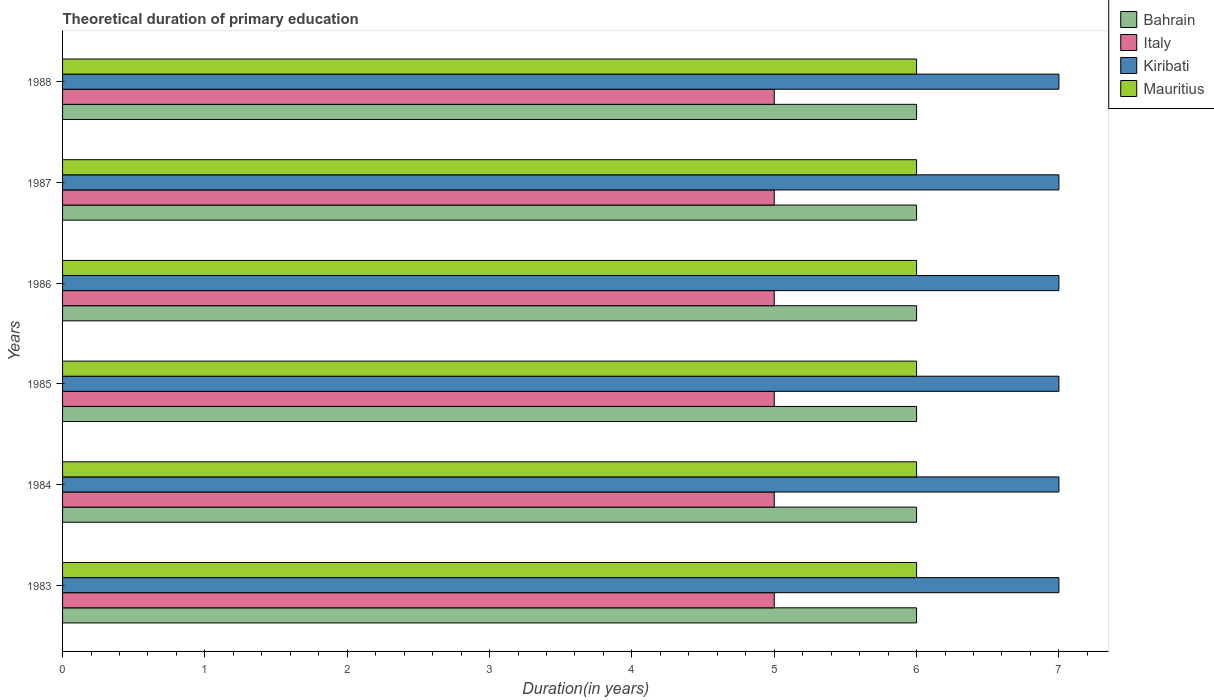How many different coloured bars are there?
Offer a terse response. 4. Are the number of bars per tick equal to the number of legend labels?
Offer a very short reply. Yes. Are the number of bars on each tick of the Y-axis equal?
Give a very brief answer. Yes. What is the label of the 3rd group of bars from the top?
Offer a terse response. 1986. In how many cases, is the number of bars for a given year not equal to the number of legend labels?
Offer a terse response. 0. What is the total theoretical duration of primary education in Mauritius in 1985?
Make the answer very short. 6. Across all years, what is the minimum total theoretical duration of primary education in Mauritius?
Provide a short and direct response. 6. What is the total total theoretical duration of primary education in Kiribati in the graph?
Offer a very short reply. 42. What is the difference between the total theoretical duration of primary education in Italy in 1986 and that in 1987?
Provide a succinct answer. 0. What is the difference between the total theoretical duration of primary education in Bahrain in 1987 and the total theoretical duration of primary education in Italy in 1986?
Your response must be concise. 1. What is the average total theoretical duration of primary education in Kiribati per year?
Keep it short and to the point. 7. In the year 1987, what is the difference between the total theoretical duration of primary education in Kiribati and total theoretical duration of primary education in Mauritius?
Provide a succinct answer. 1. What is the ratio of the total theoretical duration of primary education in Kiribati in 1986 to that in 1987?
Make the answer very short. 1. Is the difference between the total theoretical duration of primary education in Kiribati in 1984 and 1988 greater than the difference between the total theoretical duration of primary education in Mauritius in 1984 and 1988?
Provide a short and direct response. No. What is the difference between the highest and the second highest total theoretical duration of primary education in Bahrain?
Keep it short and to the point. 0. Is it the case that in every year, the sum of the total theoretical duration of primary education in Mauritius and total theoretical duration of primary education in Bahrain is greater than the sum of total theoretical duration of primary education in Kiribati and total theoretical duration of primary education in Italy?
Make the answer very short. No. Is it the case that in every year, the sum of the total theoretical duration of primary education in Italy and total theoretical duration of primary education in Kiribati is greater than the total theoretical duration of primary education in Bahrain?
Give a very brief answer. Yes. How many bars are there?
Offer a very short reply. 24. How many years are there in the graph?
Your answer should be compact. 6. Does the graph contain any zero values?
Give a very brief answer. No. Where does the legend appear in the graph?
Ensure brevity in your answer.  Top right. How many legend labels are there?
Your answer should be very brief. 4. What is the title of the graph?
Give a very brief answer. Theoretical duration of primary education. What is the label or title of the X-axis?
Give a very brief answer. Duration(in years). What is the Duration(in years) of Bahrain in 1983?
Give a very brief answer. 6. What is the Duration(in years) of Italy in 1983?
Offer a terse response. 5. What is the Duration(in years) in Kiribati in 1983?
Provide a succinct answer. 7. What is the Duration(in years) of Italy in 1984?
Offer a very short reply. 5. What is the Duration(in years) in Kiribati in 1984?
Ensure brevity in your answer.  7. What is the Duration(in years) in Bahrain in 1985?
Offer a very short reply. 6. What is the Duration(in years) of Italy in 1985?
Your answer should be compact. 5. What is the Duration(in years) in Kiribati in 1985?
Keep it short and to the point. 7. What is the Duration(in years) in Italy in 1986?
Provide a short and direct response. 5. What is the Duration(in years) in Kiribati in 1986?
Your answer should be very brief. 7. What is the Duration(in years) of Mauritius in 1987?
Keep it short and to the point. 6. What is the Duration(in years) in Italy in 1988?
Make the answer very short. 5. What is the Duration(in years) in Mauritius in 1988?
Give a very brief answer. 6. Across all years, what is the maximum Duration(in years) in Bahrain?
Ensure brevity in your answer.  6. Across all years, what is the minimum Duration(in years) of Bahrain?
Give a very brief answer. 6. Across all years, what is the minimum Duration(in years) of Mauritius?
Provide a succinct answer. 6. What is the total Duration(in years) in Bahrain in the graph?
Offer a terse response. 36. What is the total Duration(in years) of Kiribati in the graph?
Your response must be concise. 42. What is the total Duration(in years) in Mauritius in the graph?
Your response must be concise. 36. What is the difference between the Duration(in years) in Kiribati in 1983 and that in 1984?
Offer a very short reply. 0. What is the difference between the Duration(in years) of Mauritius in 1983 and that in 1984?
Your answer should be compact. 0. What is the difference between the Duration(in years) in Bahrain in 1983 and that in 1985?
Keep it short and to the point. 0. What is the difference between the Duration(in years) in Mauritius in 1983 and that in 1986?
Your answer should be very brief. 0. What is the difference between the Duration(in years) in Bahrain in 1983 and that in 1987?
Provide a succinct answer. 0. What is the difference between the Duration(in years) in Kiribati in 1983 and that in 1987?
Your response must be concise. 0. What is the difference between the Duration(in years) of Mauritius in 1983 and that in 1987?
Offer a terse response. 0. What is the difference between the Duration(in years) in Bahrain in 1983 and that in 1988?
Offer a terse response. 0. What is the difference between the Duration(in years) in Italy in 1983 and that in 1988?
Provide a short and direct response. 0. What is the difference between the Duration(in years) of Kiribati in 1983 and that in 1988?
Ensure brevity in your answer.  0. What is the difference between the Duration(in years) of Bahrain in 1984 and that in 1985?
Your response must be concise. 0. What is the difference between the Duration(in years) in Italy in 1984 and that in 1985?
Offer a terse response. 0. What is the difference between the Duration(in years) in Kiribati in 1984 and that in 1985?
Make the answer very short. 0. What is the difference between the Duration(in years) of Italy in 1984 and that in 1986?
Provide a short and direct response. 0. What is the difference between the Duration(in years) in Mauritius in 1984 and that in 1986?
Make the answer very short. 0. What is the difference between the Duration(in years) in Bahrain in 1984 and that in 1988?
Provide a succinct answer. 0. What is the difference between the Duration(in years) in Italy in 1985 and that in 1986?
Offer a terse response. 0. What is the difference between the Duration(in years) in Kiribati in 1985 and that in 1986?
Keep it short and to the point. 0. What is the difference between the Duration(in years) of Mauritius in 1985 and that in 1987?
Your response must be concise. 0. What is the difference between the Duration(in years) in Kiribati in 1985 and that in 1988?
Ensure brevity in your answer.  0. What is the difference between the Duration(in years) in Mauritius in 1985 and that in 1988?
Provide a succinct answer. 0. What is the difference between the Duration(in years) in Bahrain in 1986 and that in 1987?
Your response must be concise. 0. What is the difference between the Duration(in years) in Italy in 1986 and that in 1987?
Keep it short and to the point. 0. What is the difference between the Duration(in years) of Bahrain in 1986 and that in 1988?
Make the answer very short. 0. What is the difference between the Duration(in years) in Italy in 1986 and that in 1988?
Give a very brief answer. 0. What is the difference between the Duration(in years) in Mauritius in 1986 and that in 1988?
Ensure brevity in your answer.  0. What is the difference between the Duration(in years) of Bahrain in 1987 and that in 1988?
Offer a very short reply. 0. What is the difference between the Duration(in years) in Kiribati in 1987 and that in 1988?
Offer a very short reply. 0. What is the difference between the Duration(in years) in Mauritius in 1987 and that in 1988?
Your response must be concise. 0. What is the difference between the Duration(in years) of Bahrain in 1983 and the Duration(in years) of Kiribati in 1984?
Ensure brevity in your answer.  -1. What is the difference between the Duration(in years) in Italy in 1983 and the Duration(in years) in Kiribati in 1984?
Ensure brevity in your answer.  -2. What is the difference between the Duration(in years) of Italy in 1983 and the Duration(in years) of Mauritius in 1984?
Keep it short and to the point. -1. What is the difference between the Duration(in years) in Kiribati in 1983 and the Duration(in years) in Mauritius in 1984?
Provide a short and direct response. 1. What is the difference between the Duration(in years) of Italy in 1983 and the Duration(in years) of Kiribati in 1985?
Offer a terse response. -2. What is the difference between the Duration(in years) of Kiribati in 1983 and the Duration(in years) of Mauritius in 1985?
Give a very brief answer. 1. What is the difference between the Duration(in years) in Bahrain in 1983 and the Duration(in years) in Italy in 1986?
Ensure brevity in your answer.  1. What is the difference between the Duration(in years) of Italy in 1983 and the Duration(in years) of Kiribati in 1986?
Offer a terse response. -2. What is the difference between the Duration(in years) in Italy in 1983 and the Duration(in years) in Mauritius in 1986?
Ensure brevity in your answer.  -1. What is the difference between the Duration(in years) in Kiribati in 1983 and the Duration(in years) in Mauritius in 1986?
Ensure brevity in your answer.  1. What is the difference between the Duration(in years) in Bahrain in 1983 and the Duration(in years) in Mauritius in 1987?
Keep it short and to the point. 0. What is the difference between the Duration(in years) in Italy in 1983 and the Duration(in years) in Kiribati in 1987?
Give a very brief answer. -2. What is the difference between the Duration(in years) in Italy in 1983 and the Duration(in years) in Mauritius in 1987?
Make the answer very short. -1. What is the difference between the Duration(in years) in Kiribati in 1983 and the Duration(in years) in Mauritius in 1987?
Your response must be concise. 1. What is the difference between the Duration(in years) in Bahrain in 1983 and the Duration(in years) in Kiribati in 1988?
Your answer should be compact. -1. What is the difference between the Duration(in years) of Italy in 1983 and the Duration(in years) of Kiribati in 1988?
Ensure brevity in your answer.  -2. What is the difference between the Duration(in years) in Italy in 1983 and the Duration(in years) in Mauritius in 1988?
Offer a terse response. -1. What is the difference between the Duration(in years) in Bahrain in 1984 and the Duration(in years) in Mauritius in 1985?
Ensure brevity in your answer.  0. What is the difference between the Duration(in years) of Italy in 1984 and the Duration(in years) of Kiribati in 1985?
Make the answer very short. -2. What is the difference between the Duration(in years) of Italy in 1984 and the Duration(in years) of Mauritius in 1985?
Give a very brief answer. -1. What is the difference between the Duration(in years) in Kiribati in 1984 and the Duration(in years) in Mauritius in 1985?
Ensure brevity in your answer.  1. What is the difference between the Duration(in years) of Italy in 1984 and the Duration(in years) of Kiribati in 1986?
Offer a terse response. -2. What is the difference between the Duration(in years) of Italy in 1984 and the Duration(in years) of Mauritius in 1986?
Your answer should be compact. -1. What is the difference between the Duration(in years) of Bahrain in 1984 and the Duration(in years) of Italy in 1987?
Make the answer very short. 1. What is the difference between the Duration(in years) in Bahrain in 1984 and the Duration(in years) in Mauritius in 1987?
Offer a terse response. 0. What is the difference between the Duration(in years) of Italy in 1984 and the Duration(in years) of Kiribati in 1987?
Provide a short and direct response. -2. What is the difference between the Duration(in years) in Kiribati in 1984 and the Duration(in years) in Mauritius in 1987?
Provide a short and direct response. 1. What is the difference between the Duration(in years) in Bahrain in 1984 and the Duration(in years) in Italy in 1988?
Offer a very short reply. 1. What is the difference between the Duration(in years) of Bahrain in 1984 and the Duration(in years) of Mauritius in 1988?
Your response must be concise. 0. What is the difference between the Duration(in years) of Italy in 1984 and the Duration(in years) of Kiribati in 1988?
Keep it short and to the point. -2. What is the difference between the Duration(in years) in Bahrain in 1985 and the Duration(in years) in Italy in 1986?
Make the answer very short. 1. What is the difference between the Duration(in years) in Bahrain in 1985 and the Duration(in years) in Kiribati in 1986?
Your answer should be compact. -1. What is the difference between the Duration(in years) of Bahrain in 1985 and the Duration(in years) of Mauritius in 1986?
Give a very brief answer. 0. What is the difference between the Duration(in years) of Italy in 1985 and the Duration(in years) of Kiribati in 1986?
Make the answer very short. -2. What is the difference between the Duration(in years) in Italy in 1985 and the Duration(in years) in Mauritius in 1986?
Make the answer very short. -1. What is the difference between the Duration(in years) in Kiribati in 1985 and the Duration(in years) in Mauritius in 1986?
Provide a succinct answer. 1. What is the difference between the Duration(in years) in Bahrain in 1985 and the Duration(in years) in Kiribati in 1987?
Keep it short and to the point. -1. What is the difference between the Duration(in years) in Italy in 1985 and the Duration(in years) in Kiribati in 1987?
Provide a succinct answer. -2. What is the difference between the Duration(in years) in Kiribati in 1985 and the Duration(in years) in Mauritius in 1987?
Your response must be concise. 1. What is the difference between the Duration(in years) of Bahrain in 1985 and the Duration(in years) of Italy in 1988?
Provide a short and direct response. 1. What is the difference between the Duration(in years) in Italy in 1985 and the Duration(in years) in Kiribati in 1988?
Keep it short and to the point. -2. What is the difference between the Duration(in years) in Kiribati in 1985 and the Duration(in years) in Mauritius in 1988?
Your answer should be very brief. 1. What is the difference between the Duration(in years) of Bahrain in 1986 and the Duration(in years) of Italy in 1987?
Provide a succinct answer. 1. What is the difference between the Duration(in years) of Bahrain in 1986 and the Duration(in years) of Kiribati in 1987?
Offer a very short reply. -1. What is the difference between the Duration(in years) of Bahrain in 1986 and the Duration(in years) of Mauritius in 1987?
Make the answer very short. 0. What is the difference between the Duration(in years) in Bahrain in 1986 and the Duration(in years) in Italy in 1988?
Your response must be concise. 1. What is the difference between the Duration(in years) of Bahrain in 1987 and the Duration(in years) of Italy in 1988?
Your answer should be very brief. 1. What is the difference between the Duration(in years) of Italy in 1987 and the Duration(in years) of Kiribati in 1988?
Offer a terse response. -2. What is the difference between the Duration(in years) in Italy in 1987 and the Duration(in years) in Mauritius in 1988?
Ensure brevity in your answer.  -1. What is the difference between the Duration(in years) in Kiribati in 1987 and the Duration(in years) in Mauritius in 1988?
Your answer should be compact. 1. What is the average Duration(in years) of Italy per year?
Make the answer very short. 5. What is the average Duration(in years) in Kiribati per year?
Ensure brevity in your answer.  7. In the year 1983, what is the difference between the Duration(in years) in Bahrain and Duration(in years) in Italy?
Offer a terse response. 1. In the year 1984, what is the difference between the Duration(in years) in Bahrain and Duration(in years) in Italy?
Keep it short and to the point. 1. In the year 1984, what is the difference between the Duration(in years) in Bahrain and Duration(in years) in Mauritius?
Offer a terse response. 0. In the year 1984, what is the difference between the Duration(in years) of Italy and Duration(in years) of Kiribati?
Provide a succinct answer. -2. In the year 1985, what is the difference between the Duration(in years) in Bahrain and Duration(in years) in Italy?
Offer a terse response. 1. In the year 1985, what is the difference between the Duration(in years) of Bahrain and Duration(in years) of Mauritius?
Give a very brief answer. 0. In the year 1985, what is the difference between the Duration(in years) of Italy and Duration(in years) of Mauritius?
Ensure brevity in your answer.  -1. In the year 1985, what is the difference between the Duration(in years) of Kiribati and Duration(in years) of Mauritius?
Ensure brevity in your answer.  1. In the year 1986, what is the difference between the Duration(in years) of Bahrain and Duration(in years) of Italy?
Your response must be concise. 1. In the year 1986, what is the difference between the Duration(in years) of Bahrain and Duration(in years) of Kiribati?
Give a very brief answer. -1. In the year 1986, what is the difference between the Duration(in years) of Bahrain and Duration(in years) of Mauritius?
Provide a short and direct response. 0. In the year 1986, what is the difference between the Duration(in years) of Italy and Duration(in years) of Kiribati?
Make the answer very short. -2. In the year 1986, what is the difference between the Duration(in years) in Kiribati and Duration(in years) in Mauritius?
Your response must be concise. 1. In the year 1987, what is the difference between the Duration(in years) of Bahrain and Duration(in years) of Italy?
Provide a succinct answer. 1. In the year 1987, what is the difference between the Duration(in years) in Bahrain and Duration(in years) in Kiribati?
Keep it short and to the point. -1. In the year 1987, what is the difference between the Duration(in years) of Italy and Duration(in years) of Kiribati?
Give a very brief answer. -2. In the year 1987, what is the difference between the Duration(in years) in Italy and Duration(in years) in Mauritius?
Offer a terse response. -1. In the year 1988, what is the difference between the Duration(in years) in Bahrain and Duration(in years) in Kiribati?
Offer a terse response. -1. In the year 1988, what is the difference between the Duration(in years) of Bahrain and Duration(in years) of Mauritius?
Provide a succinct answer. 0. In the year 1988, what is the difference between the Duration(in years) in Kiribati and Duration(in years) in Mauritius?
Ensure brevity in your answer.  1. What is the ratio of the Duration(in years) of Bahrain in 1983 to that in 1984?
Give a very brief answer. 1. What is the ratio of the Duration(in years) of Kiribati in 1983 to that in 1984?
Give a very brief answer. 1. What is the ratio of the Duration(in years) in Mauritius in 1983 to that in 1984?
Provide a succinct answer. 1. What is the ratio of the Duration(in years) of Bahrain in 1983 to that in 1985?
Offer a terse response. 1. What is the ratio of the Duration(in years) in Bahrain in 1983 to that in 1986?
Provide a succinct answer. 1. What is the ratio of the Duration(in years) in Italy in 1983 to that in 1986?
Your answer should be very brief. 1. What is the ratio of the Duration(in years) of Kiribati in 1983 to that in 1986?
Make the answer very short. 1. What is the ratio of the Duration(in years) of Mauritius in 1983 to that in 1987?
Ensure brevity in your answer.  1. What is the ratio of the Duration(in years) in Italy in 1983 to that in 1988?
Make the answer very short. 1. What is the ratio of the Duration(in years) in Italy in 1984 to that in 1985?
Make the answer very short. 1. What is the ratio of the Duration(in years) in Kiribati in 1984 to that in 1985?
Give a very brief answer. 1. What is the ratio of the Duration(in years) in Mauritius in 1984 to that in 1985?
Offer a very short reply. 1. What is the ratio of the Duration(in years) in Bahrain in 1984 to that in 1986?
Provide a succinct answer. 1. What is the ratio of the Duration(in years) of Italy in 1984 to that in 1986?
Make the answer very short. 1. What is the ratio of the Duration(in years) in Bahrain in 1984 to that in 1987?
Ensure brevity in your answer.  1. What is the ratio of the Duration(in years) of Mauritius in 1984 to that in 1987?
Offer a very short reply. 1. What is the ratio of the Duration(in years) in Bahrain in 1984 to that in 1988?
Keep it short and to the point. 1. What is the ratio of the Duration(in years) in Kiribati in 1984 to that in 1988?
Your answer should be very brief. 1. What is the ratio of the Duration(in years) in Mauritius in 1984 to that in 1988?
Ensure brevity in your answer.  1. What is the ratio of the Duration(in years) of Italy in 1985 to that in 1986?
Offer a terse response. 1. What is the ratio of the Duration(in years) in Kiribati in 1985 to that in 1986?
Your answer should be compact. 1. What is the ratio of the Duration(in years) in Mauritius in 1985 to that in 1986?
Keep it short and to the point. 1. What is the ratio of the Duration(in years) of Bahrain in 1985 to that in 1987?
Your answer should be compact. 1. What is the ratio of the Duration(in years) in Italy in 1985 to that in 1987?
Make the answer very short. 1. What is the ratio of the Duration(in years) of Kiribati in 1985 to that in 1987?
Make the answer very short. 1. What is the ratio of the Duration(in years) of Italy in 1985 to that in 1988?
Ensure brevity in your answer.  1. What is the ratio of the Duration(in years) of Italy in 1986 to that in 1987?
Your response must be concise. 1. What is the ratio of the Duration(in years) of Bahrain in 1986 to that in 1988?
Ensure brevity in your answer.  1. What is the ratio of the Duration(in years) in Italy in 1986 to that in 1988?
Keep it short and to the point. 1. What is the ratio of the Duration(in years) of Mauritius in 1986 to that in 1988?
Provide a succinct answer. 1. What is the difference between the highest and the second highest Duration(in years) in Bahrain?
Offer a terse response. 0. What is the difference between the highest and the second highest Duration(in years) of Italy?
Your answer should be very brief. 0. What is the difference between the highest and the second highest Duration(in years) in Kiribati?
Keep it short and to the point. 0. What is the difference between the highest and the second highest Duration(in years) of Mauritius?
Ensure brevity in your answer.  0. 